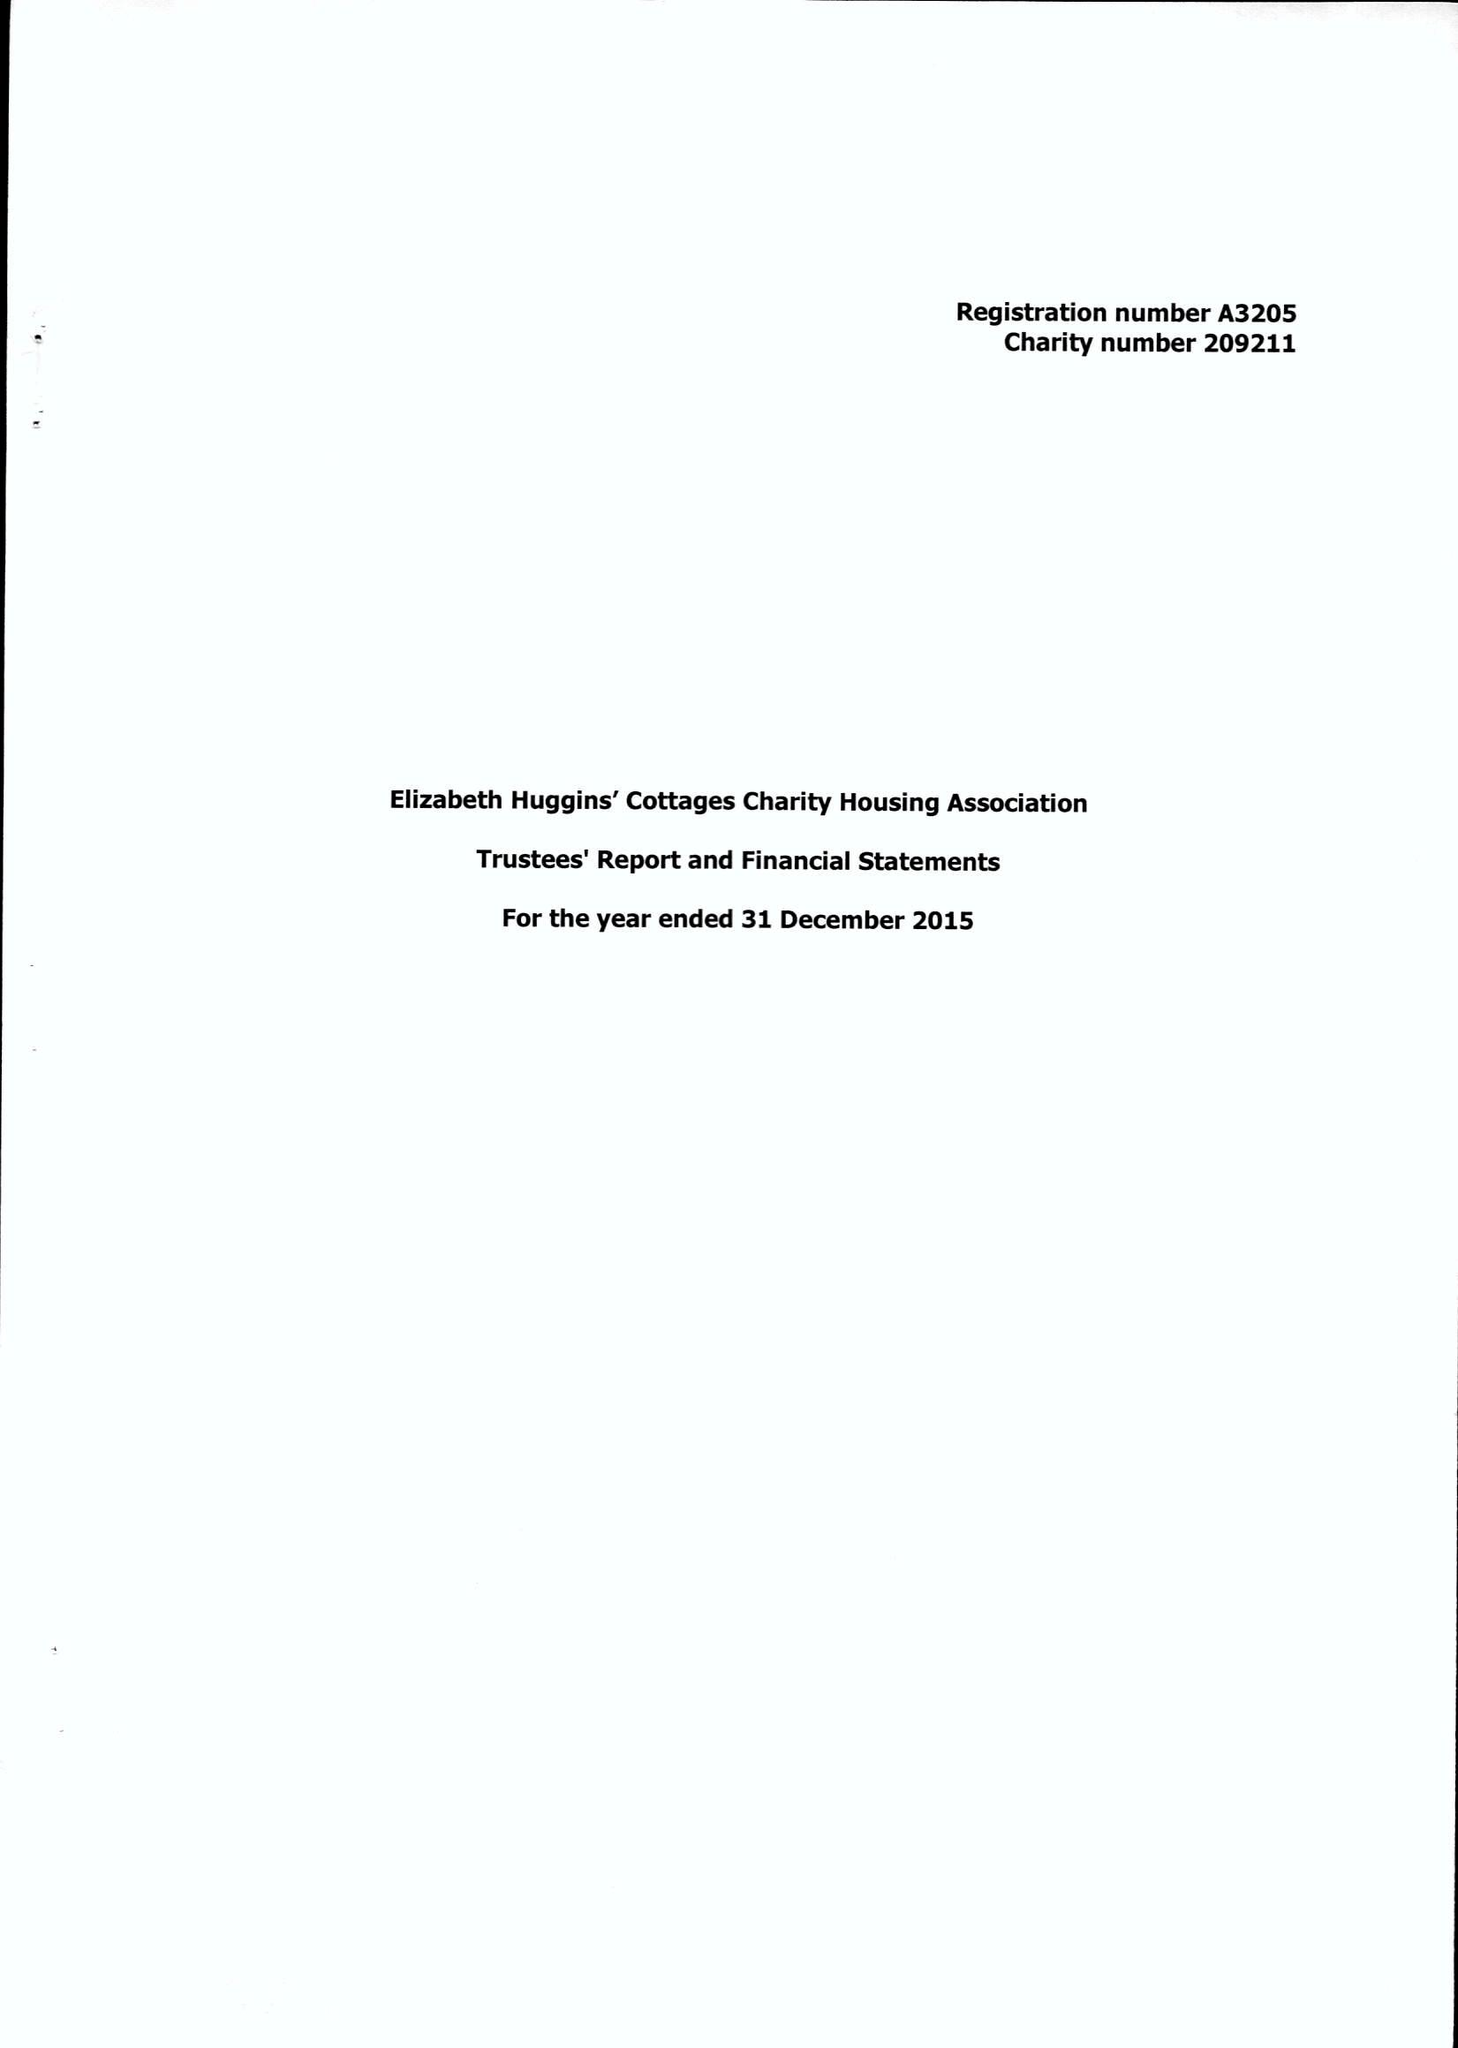What is the value for the address__street_line?
Answer the question using a single word or phrase. 14 LONDON ROAD 